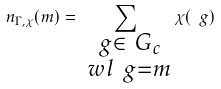Convert formula to latex. <formula><loc_0><loc_0><loc_500><loc_500>n _ { \Gamma , \chi } ( m ) = \sum _ { \substack { \ g \in \ G _ { c } \\ \ w l \ g = m } } \chi ( \ g )</formula> 